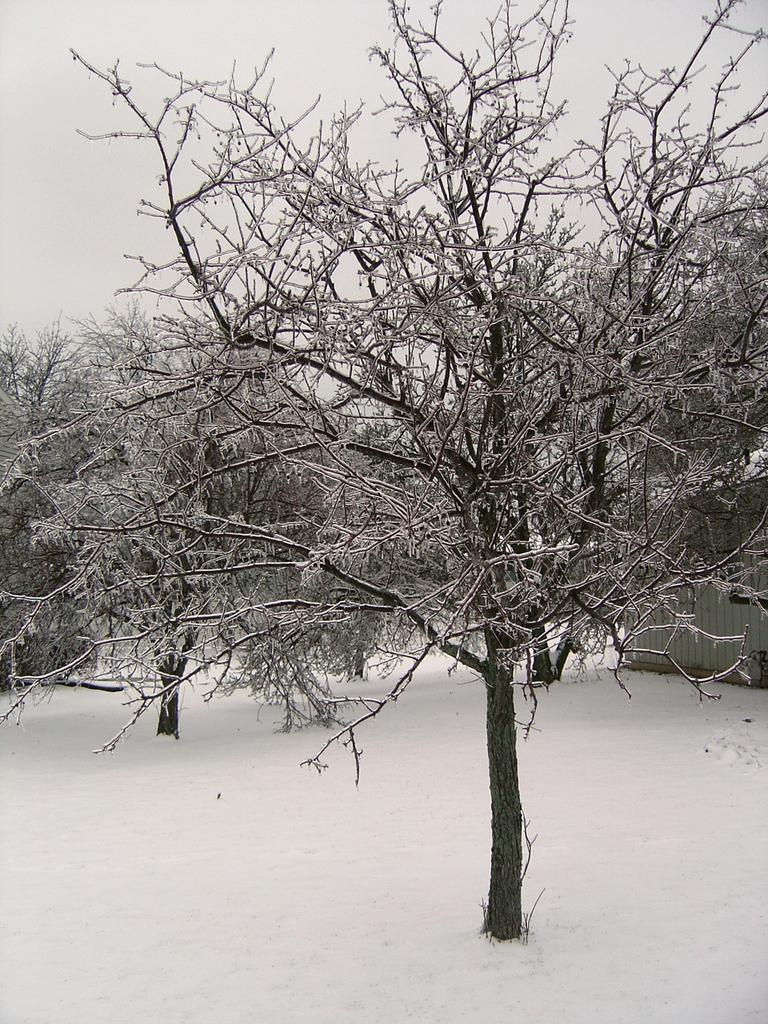What type of vegetation is present in the image? There are dried trees in the image. What is the weather condition in the image? There is snow visible in the image. What is the color scheme of the image? The image is in black and white. What type of lead can be seen being dropped in the image? There is no lead or any object being dropped present in the image. What type of meal is being prepared or served in the image? There is no meal preparation or serving visible in the image. 